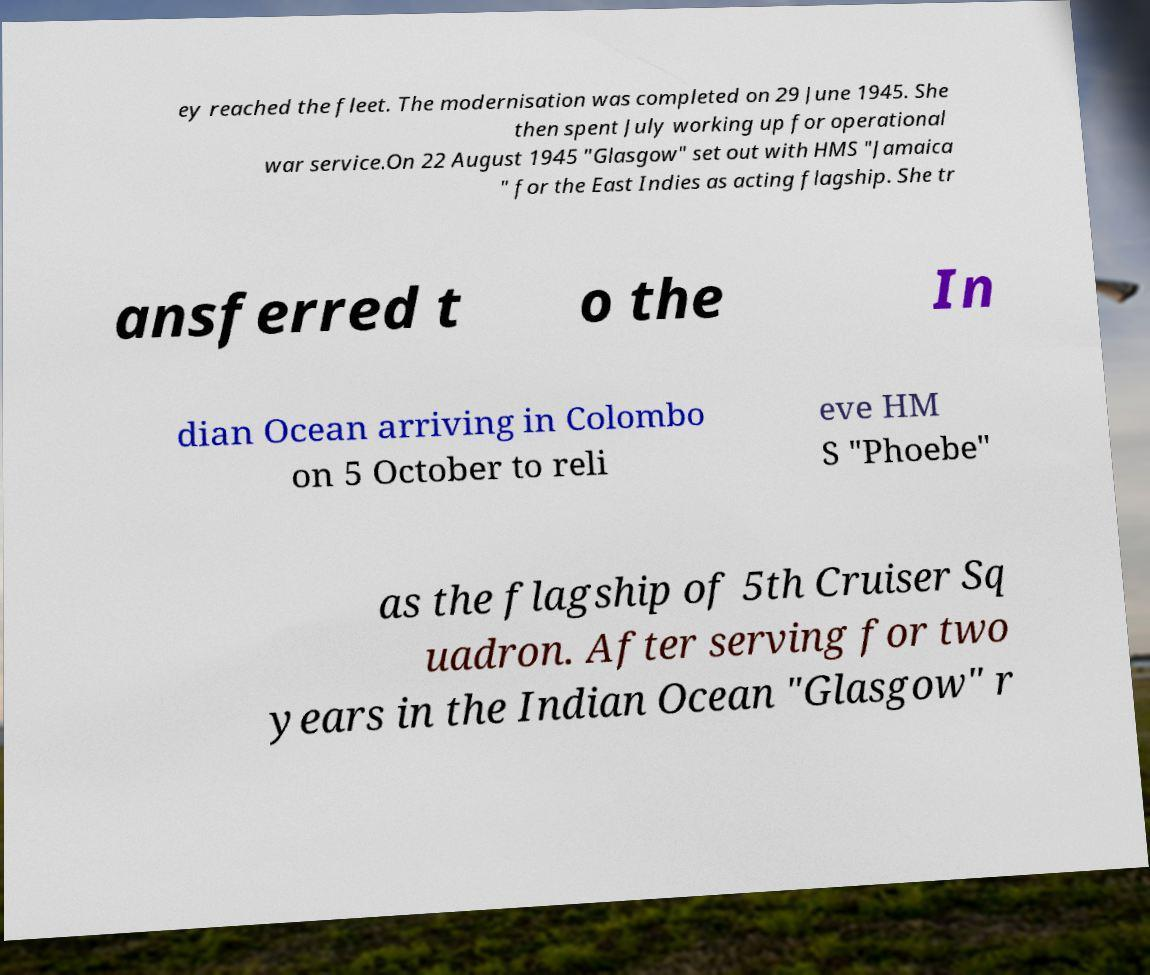Can you read and provide the text displayed in the image?This photo seems to have some interesting text. Can you extract and type it out for me? ey reached the fleet. The modernisation was completed on 29 June 1945. She then spent July working up for operational war service.On 22 August 1945 "Glasgow" set out with HMS "Jamaica " for the East Indies as acting flagship. She tr ansferred t o the In dian Ocean arriving in Colombo on 5 October to reli eve HM S "Phoebe" as the flagship of 5th Cruiser Sq uadron. After serving for two years in the Indian Ocean "Glasgow" r 